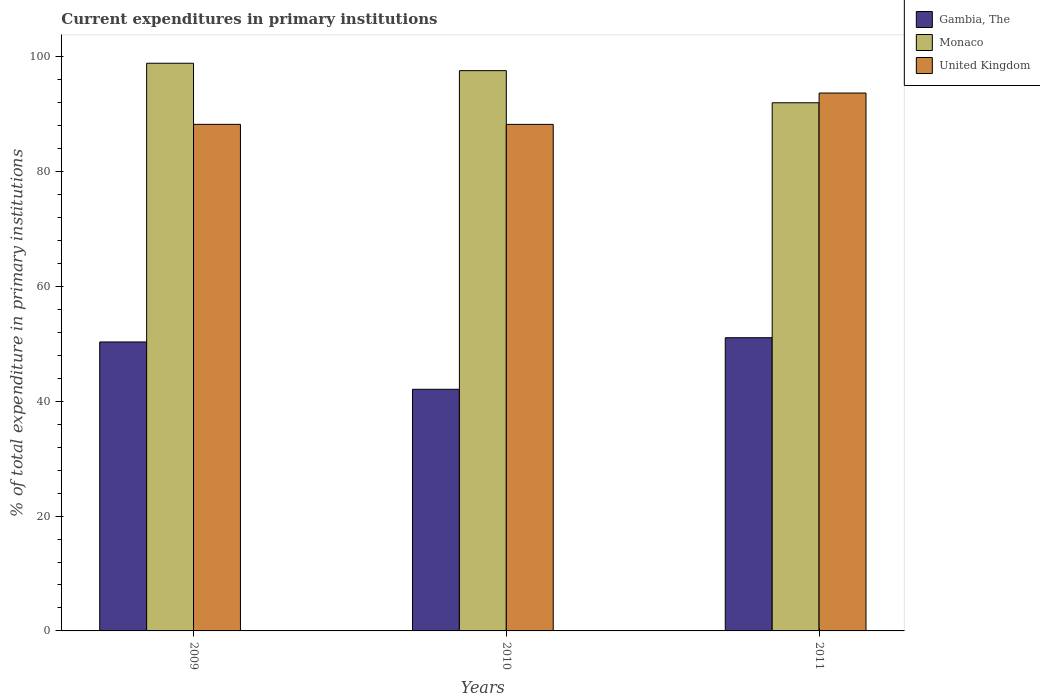How many groups of bars are there?
Your response must be concise. 3. Are the number of bars per tick equal to the number of legend labels?
Give a very brief answer. Yes. Are the number of bars on each tick of the X-axis equal?
Give a very brief answer. Yes. How many bars are there on the 3rd tick from the right?
Keep it short and to the point. 3. In how many cases, is the number of bars for a given year not equal to the number of legend labels?
Ensure brevity in your answer.  0. What is the current expenditures in primary institutions in Gambia, The in 2009?
Offer a very short reply. 50.33. Across all years, what is the maximum current expenditures in primary institutions in United Kingdom?
Offer a terse response. 93.68. Across all years, what is the minimum current expenditures in primary institutions in Monaco?
Give a very brief answer. 91.98. In which year was the current expenditures in primary institutions in United Kingdom maximum?
Give a very brief answer. 2011. In which year was the current expenditures in primary institutions in Gambia, The minimum?
Offer a terse response. 2010. What is the total current expenditures in primary institutions in Gambia, The in the graph?
Offer a very short reply. 143.47. What is the difference between the current expenditures in primary institutions in Gambia, The in 2009 and that in 2011?
Provide a succinct answer. -0.74. What is the difference between the current expenditures in primary institutions in Monaco in 2011 and the current expenditures in primary institutions in Gambia, The in 2010?
Keep it short and to the point. 49.9. What is the average current expenditures in primary institutions in United Kingdom per year?
Keep it short and to the point. 90.04. In the year 2010, what is the difference between the current expenditures in primary institutions in United Kingdom and current expenditures in primary institutions in Monaco?
Your response must be concise. -9.36. In how many years, is the current expenditures in primary institutions in Monaco greater than 96 %?
Your answer should be very brief. 2. What is the ratio of the current expenditures in primary institutions in United Kingdom in 2009 to that in 2010?
Offer a very short reply. 1. What is the difference between the highest and the second highest current expenditures in primary institutions in United Kingdom?
Offer a very short reply. 5.45. What is the difference between the highest and the lowest current expenditures in primary institutions in Gambia, The?
Offer a very short reply. 8.98. Is the sum of the current expenditures in primary institutions in United Kingdom in 2010 and 2011 greater than the maximum current expenditures in primary institutions in Gambia, The across all years?
Ensure brevity in your answer.  Yes. What does the 1st bar from the left in 2009 represents?
Give a very brief answer. Gambia, The. What does the 3rd bar from the right in 2010 represents?
Provide a short and direct response. Gambia, The. Are the values on the major ticks of Y-axis written in scientific E-notation?
Offer a very short reply. No. How many legend labels are there?
Your answer should be very brief. 3. What is the title of the graph?
Your answer should be compact. Current expenditures in primary institutions. Does "Israel" appear as one of the legend labels in the graph?
Your answer should be compact. No. What is the label or title of the X-axis?
Offer a very short reply. Years. What is the label or title of the Y-axis?
Offer a very short reply. % of total expenditure in primary institutions. What is the % of total expenditure in primary institutions of Gambia, The in 2009?
Give a very brief answer. 50.33. What is the % of total expenditure in primary institutions in Monaco in 2009?
Give a very brief answer. 98.87. What is the % of total expenditure in primary institutions of United Kingdom in 2009?
Your response must be concise. 88.23. What is the % of total expenditure in primary institutions of Gambia, The in 2010?
Your answer should be very brief. 42.08. What is the % of total expenditure in primary institutions in Monaco in 2010?
Offer a terse response. 97.58. What is the % of total expenditure in primary institutions in United Kingdom in 2010?
Ensure brevity in your answer.  88.22. What is the % of total expenditure in primary institutions in Gambia, The in 2011?
Make the answer very short. 51.07. What is the % of total expenditure in primary institutions of Monaco in 2011?
Your answer should be compact. 91.98. What is the % of total expenditure in primary institutions in United Kingdom in 2011?
Offer a very short reply. 93.68. Across all years, what is the maximum % of total expenditure in primary institutions in Gambia, The?
Make the answer very short. 51.07. Across all years, what is the maximum % of total expenditure in primary institutions of Monaco?
Make the answer very short. 98.87. Across all years, what is the maximum % of total expenditure in primary institutions of United Kingdom?
Provide a short and direct response. 93.68. Across all years, what is the minimum % of total expenditure in primary institutions of Gambia, The?
Offer a very short reply. 42.08. Across all years, what is the minimum % of total expenditure in primary institutions of Monaco?
Keep it short and to the point. 91.98. Across all years, what is the minimum % of total expenditure in primary institutions of United Kingdom?
Ensure brevity in your answer.  88.22. What is the total % of total expenditure in primary institutions in Gambia, The in the graph?
Provide a short and direct response. 143.47. What is the total % of total expenditure in primary institutions in Monaco in the graph?
Make the answer very short. 288.43. What is the total % of total expenditure in primary institutions of United Kingdom in the graph?
Keep it short and to the point. 270.12. What is the difference between the % of total expenditure in primary institutions in Gambia, The in 2009 and that in 2010?
Your answer should be compact. 8.24. What is the difference between the % of total expenditure in primary institutions of Monaco in 2009 and that in 2010?
Provide a succinct answer. 1.29. What is the difference between the % of total expenditure in primary institutions of United Kingdom in 2009 and that in 2010?
Provide a short and direct response. 0.01. What is the difference between the % of total expenditure in primary institutions in Gambia, The in 2009 and that in 2011?
Provide a short and direct response. -0.74. What is the difference between the % of total expenditure in primary institutions of Monaco in 2009 and that in 2011?
Keep it short and to the point. 6.88. What is the difference between the % of total expenditure in primary institutions in United Kingdom in 2009 and that in 2011?
Provide a short and direct response. -5.45. What is the difference between the % of total expenditure in primary institutions of Gambia, The in 2010 and that in 2011?
Offer a very short reply. -8.98. What is the difference between the % of total expenditure in primary institutions in Monaco in 2010 and that in 2011?
Your answer should be very brief. 5.6. What is the difference between the % of total expenditure in primary institutions in United Kingdom in 2010 and that in 2011?
Give a very brief answer. -5.46. What is the difference between the % of total expenditure in primary institutions of Gambia, The in 2009 and the % of total expenditure in primary institutions of Monaco in 2010?
Your answer should be compact. -47.25. What is the difference between the % of total expenditure in primary institutions of Gambia, The in 2009 and the % of total expenditure in primary institutions of United Kingdom in 2010?
Your answer should be compact. -37.89. What is the difference between the % of total expenditure in primary institutions of Monaco in 2009 and the % of total expenditure in primary institutions of United Kingdom in 2010?
Provide a succinct answer. 10.65. What is the difference between the % of total expenditure in primary institutions in Gambia, The in 2009 and the % of total expenditure in primary institutions in Monaco in 2011?
Provide a short and direct response. -41.66. What is the difference between the % of total expenditure in primary institutions in Gambia, The in 2009 and the % of total expenditure in primary institutions in United Kingdom in 2011?
Ensure brevity in your answer.  -43.35. What is the difference between the % of total expenditure in primary institutions of Monaco in 2009 and the % of total expenditure in primary institutions of United Kingdom in 2011?
Provide a succinct answer. 5.19. What is the difference between the % of total expenditure in primary institutions in Gambia, The in 2010 and the % of total expenditure in primary institutions in Monaco in 2011?
Your answer should be compact. -49.9. What is the difference between the % of total expenditure in primary institutions in Gambia, The in 2010 and the % of total expenditure in primary institutions in United Kingdom in 2011?
Provide a succinct answer. -51.6. What is the difference between the % of total expenditure in primary institutions in Monaco in 2010 and the % of total expenditure in primary institutions in United Kingdom in 2011?
Your answer should be very brief. 3.9. What is the average % of total expenditure in primary institutions of Gambia, The per year?
Your answer should be very brief. 47.82. What is the average % of total expenditure in primary institutions in Monaco per year?
Your answer should be compact. 96.14. What is the average % of total expenditure in primary institutions of United Kingdom per year?
Offer a very short reply. 90.04. In the year 2009, what is the difference between the % of total expenditure in primary institutions in Gambia, The and % of total expenditure in primary institutions in Monaco?
Ensure brevity in your answer.  -48.54. In the year 2009, what is the difference between the % of total expenditure in primary institutions of Gambia, The and % of total expenditure in primary institutions of United Kingdom?
Give a very brief answer. -37.9. In the year 2009, what is the difference between the % of total expenditure in primary institutions of Monaco and % of total expenditure in primary institutions of United Kingdom?
Ensure brevity in your answer.  10.64. In the year 2010, what is the difference between the % of total expenditure in primary institutions in Gambia, The and % of total expenditure in primary institutions in Monaco?
Keep it short and to the point. -55.5. In the year 2010, what is the difference between the % of total expenditure in primary institutions in Gambia, The and % of total expenditure in primary institutions in United Kingdom?
Your answer should be compact. -46.14. In the year 2010, what is the difference between the % of total expenditure in primary institutions of Monaco and % of total expenditure in primary institutions of United Kingdom?
Your answer should be very brief. 9.36. In the year 2011, what is the difference between the % of total expenditure in primary institutions in Gambia, The and % of total expenditure in primary institutions in Monaco?
Provide a succinct answer. -40.92. In the year 2011, what is the difference between the % of total expenditure in primary institutions in Gambia, The and % of total expenditure in primary institutions in United Kingdom?
Your answer should be very brief. -42.61. In the year 2011, what is the difference between the % of total expenditure in primary institutions of Monaco and % of total expenditure in primary institutions of United Kingdom?
Ensure brevity in your answer.  -1.7. What is the ratio of the % of total expenditure in primary institutions of Gambia, The in 2009 to that in 2010?
Give a very brief answer. 1.2. What is the ratio of the % of total expenditure in primary institutions in Monaco in 2009 to that in 2010?
Your response must be concise. 1.01. What is the ratio of the % of total expenditure in primary institutions of United Kingdom in 2009 to that in 2010?
Provide a succinct answer. 1. What is the ratio of the % of total expenditure in primary institutions in Gambia, The in 2009 to that in 2011?
Make the answer very short. 0.99. What is the ratio of the % of total expenditure in primary institutions of Monaco in 2009 to that in 2011?
Your answer should be compact. 1.07. What is the ratio of the % of total expenditure in primary institutions in United Kingdom in 2009 to that in 2011?
Give a very brief answer. 0.94. What is the ratio of the % of total expenditure in primary institutions of Gambia, The in 2010 to that in 2011?
Keep it short and to the point. 0.82. What is the ratio of the % of total expenditure in primary institutions in Monaco in 2010 to that in 2011?
Ensure brevity in your answer.  1.06. What is the ratio of the % of total expenditure in primary institutions of United Kingdom in 2010 to that in 2011?
Your response must be concise. 0.94. What is the difference between the highest and the second highest % of total expenditure in primary institutions in Gambia, The?
Offer a terse response. 0.74. What is the difference between the highest and the second highest % of total expenditure in primary institutions of Monaco?
Ensure brevity in your answer.  1.29. What is the difference between the highest and the second highest % of total expenditure in primary institutions in United Kingdom?
Give a very brief answer. 5.45. What is the difference between the highest and the lowest % of total expenditure in primary institutions of Gambia, The?
Offer a very short reply. 8.98. What is the difference between the highest and the lowest % of total expenditure in primary institutions in Monaco?
Provide a short and direct response. 6.88. What is the difference between the highest and the lowest % of total expenditure in primary institutions in United Kingdom?
Keep it short and to the point. 5.46. 